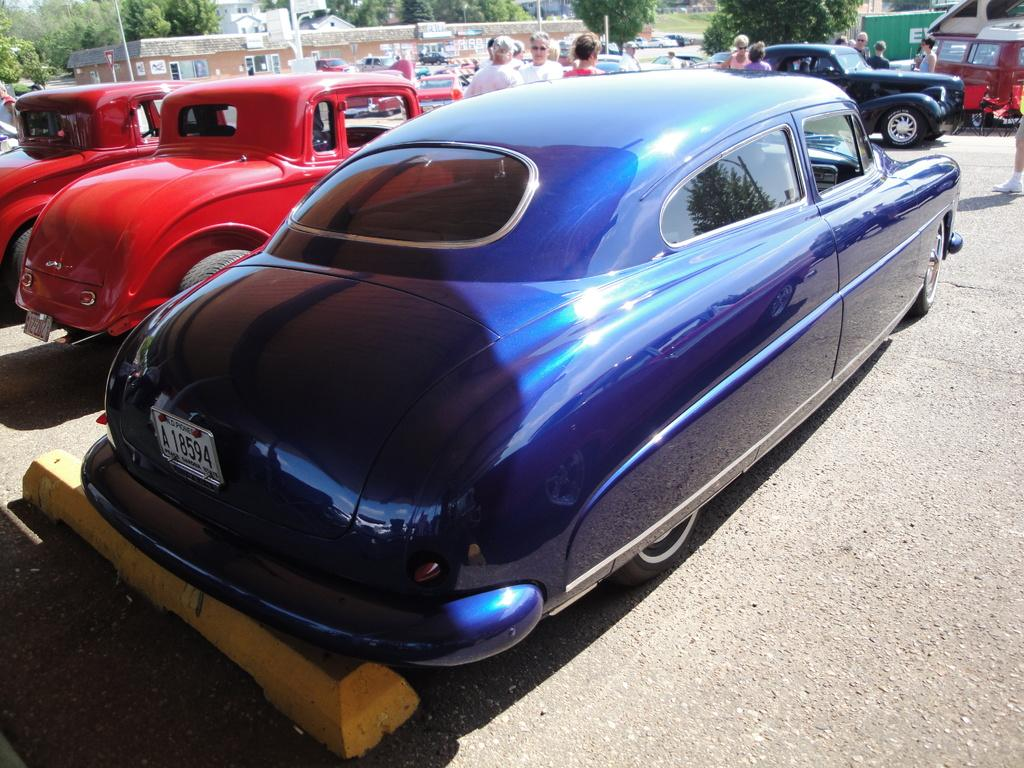What can be seen running through the image? There is a path in the image. What is moving along the path? There are cars and people on the path. What can be seen in the distance in the image? There are buildings, trees, and poles in the background of the image. What type of sound can be heard coming from the chickens in the image? There are no chickens present in the image, so it's not possible to determine what, if any, sounds might be heard. 